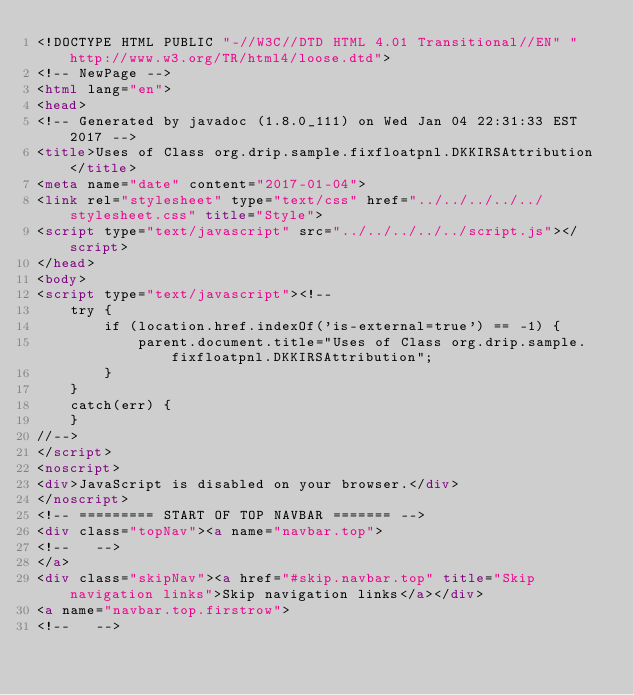<code> <loc_0><loc_0><loc_500><loc_500><_HTML_><!DOCTYPE HTML PUBLIC "-//W3C//DTD HTML 4.01 Transitional//EN" "http://www.w3.org/TR/html4/loose.dtd">
<!-- NewPage -->
<html lang="en">
<head>
<!-- Generated by javadoc (1.8.0_111) on Wed Jan 04 22:31:33 EST 2017 -->
<title>Uses of Class org.drip.sample.fixfloatpnl.DKKIRSAttribution</title>
<meta name="date" content="2017-01-04">
<link rel="stylesheet" type="text/css" href="../../../../../stylesheet.css" title="Style">
<script type="text/javascript" src="../../../../../script.js"></script>
</head>
<body>
<script type="text/javascript"><!--
    try {
        if (location.href.indexOf('is-external=true') == -1) {
            parent.document.title="Uses of Class org.drip.sample.fixfloatpnl.DKKIRSAttribution";
        }
    }
    catch(err) {
    }
//-->
</script>
<noscript>
<div>JavaScript is disabled on your browser.</div>
</noscript>
<!-- ========= START OF TOP NAVBAR ======= -->
<div class="topNav"><a name="navbar.top">
<!--   -->
</a>
<div class="skipNav"><a href="#skip.navbar.top" title="Skip navigation links">Skip navigation links</a></div>
<a name="navbar.top.firstrow">
<!--   --></code> 